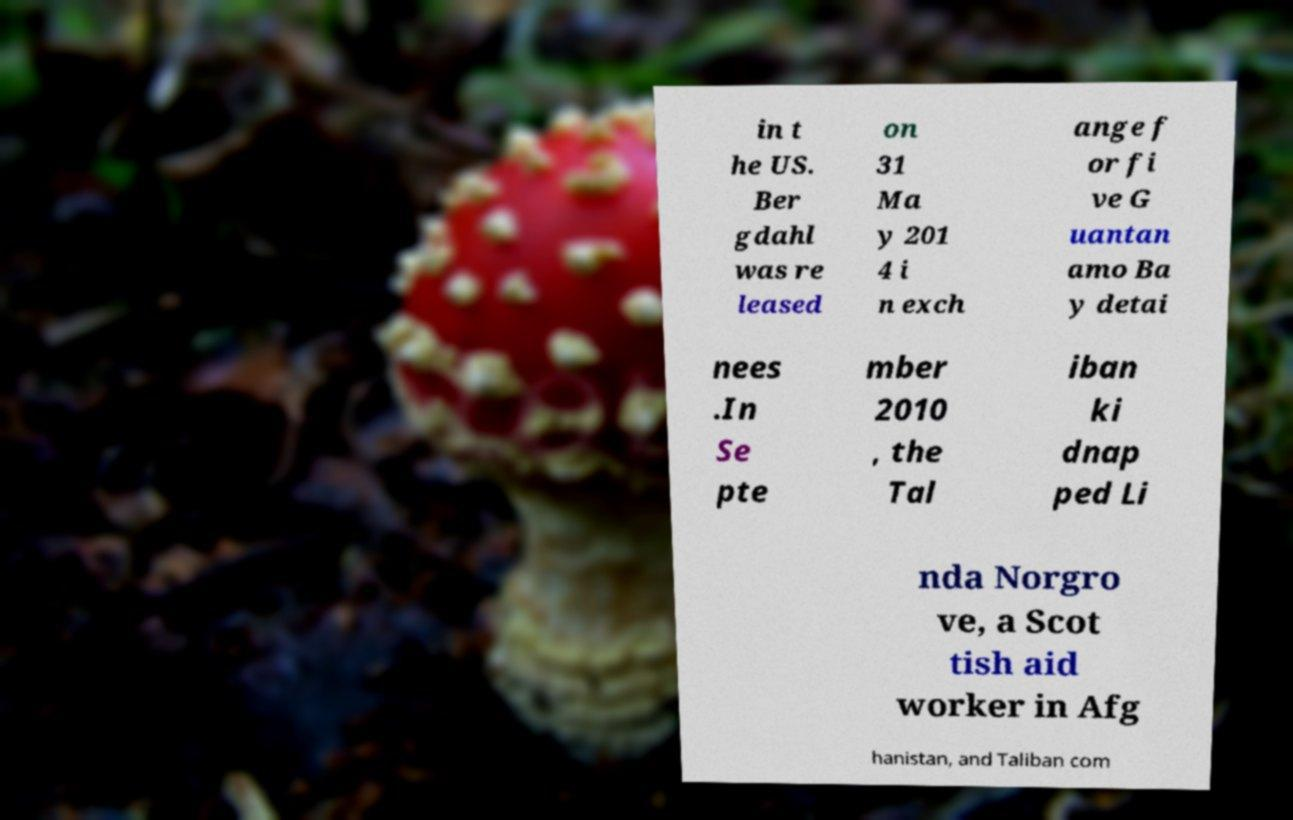Can you read and provide the text displayed in the image?This photo seems to have some interesting text. Can you extract and type it out for me? in t he US. Ber gdahl was re leased on 31 Ma y 201 4 i n exch ange f or fi ve G uantan amo Ba y detai nees .In Se pte mber 2010 , the Tal iban ki dnap ped Li nda Norgro ve, a Scot tish aid worker in Afg hanistan, and Taliban com 